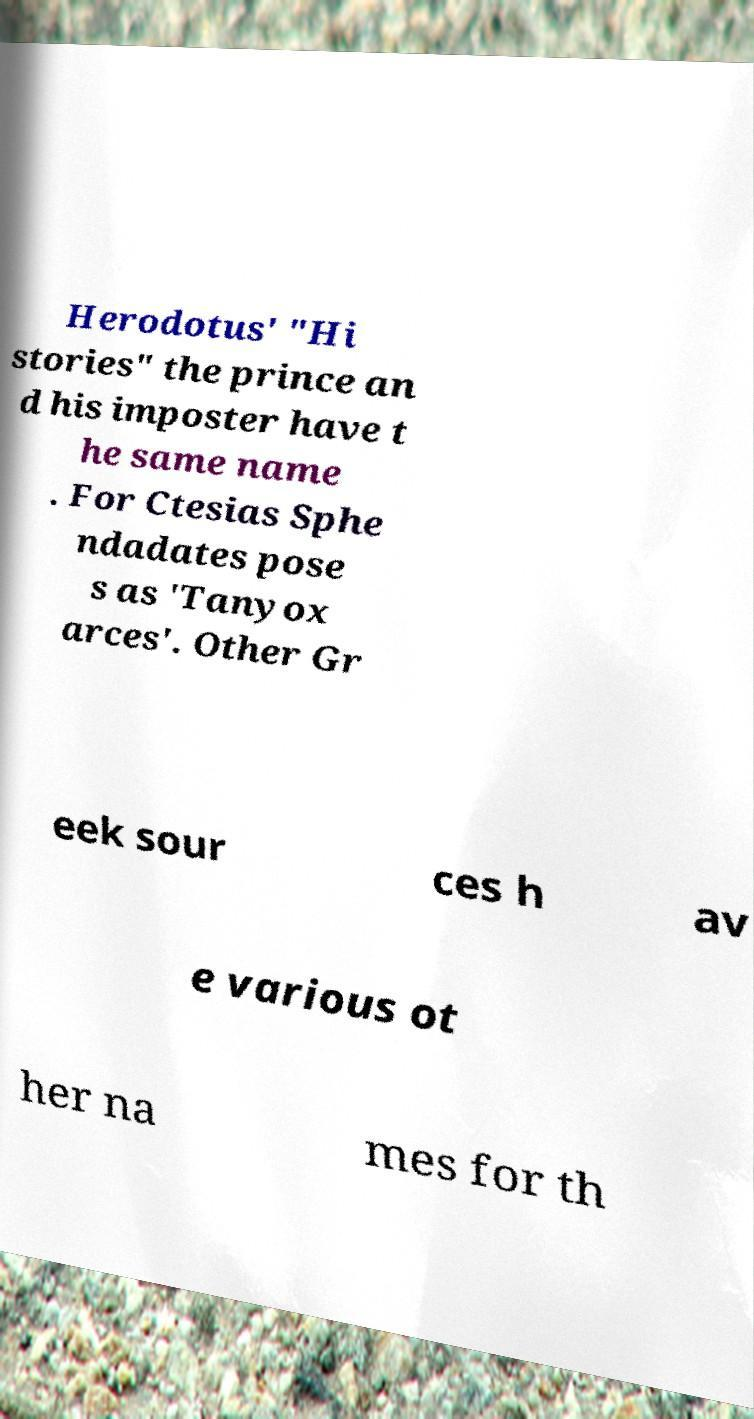For documentation purposes, I need the text within this image transcribed. Could you provide that? Herodotus' "Hi stories" the prince an d his imposter have t he same name . For Ctesias Sphe ndadates pose s as 'Tanyox arces'. Other Gr eek sour ces h av e various ot her na mes for th 